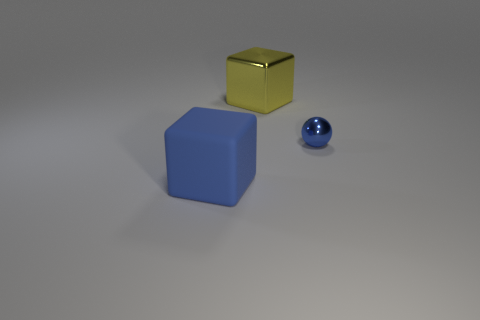How many shiny objects are either large blocks or tiny spheres?
Provide a succinct answer. 2. The block that is in front of the metal ball on the right side of the big thing that is in front of the large yellow object is made of what material?
Keep it short and to the point. Rubber. Is the shape of the large object to the right of the large blue rubber thing the same as the object right of the yellow shiny block?
Ensure brevity in your answer.  No. There is a large cube that is behind the cube in front of the tiny blue ball; what is its color?
Your answer should be very brief. Yellow. How many spheres are either blue rubber things or yellow metal objects?
Give a very brief answer. 0. There is a large cube that is in front of the big thing that is behind the sphere; what number of large blocks are on the right side of it?
Keep it short and to the point. 1. There is a block that is the same color as the small ball; what is its size?
Offer a very short reply. Large. Are there any large things made of the same material as the yellow cube?
Ensure brevity in your answer.  No. Is the yellow thing made of the same material as the big blue block?
Your response must be concise. No. There is a object that is on the right side of the big shiny object; what number of small blue shiny spheres are right of it?
Your response must be concise. 0. 